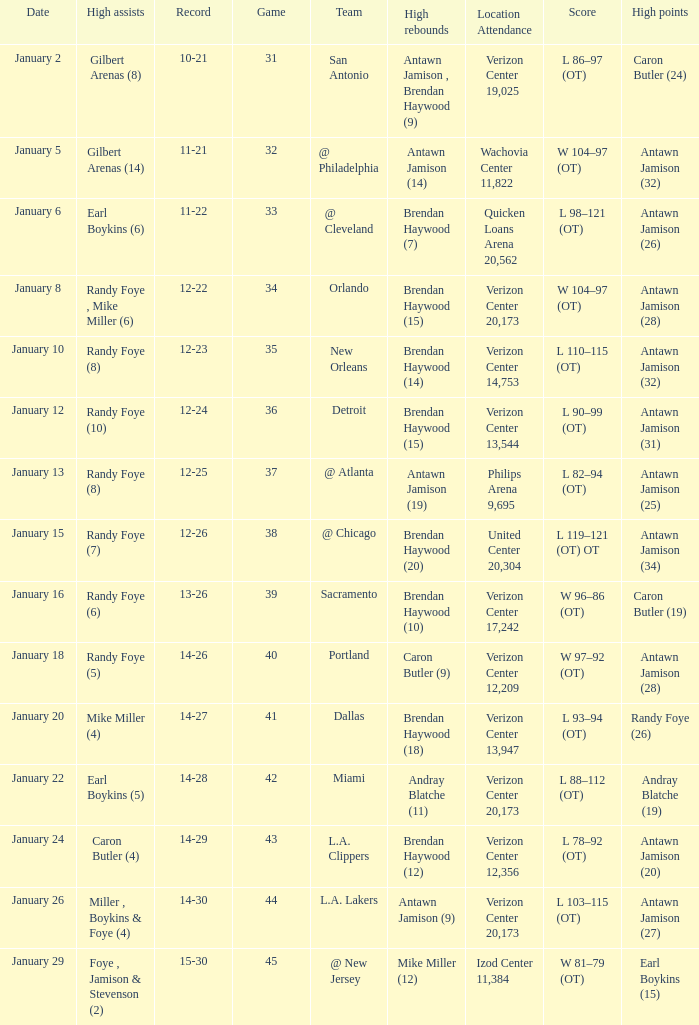How many people got high points in game 35? 1.0. 